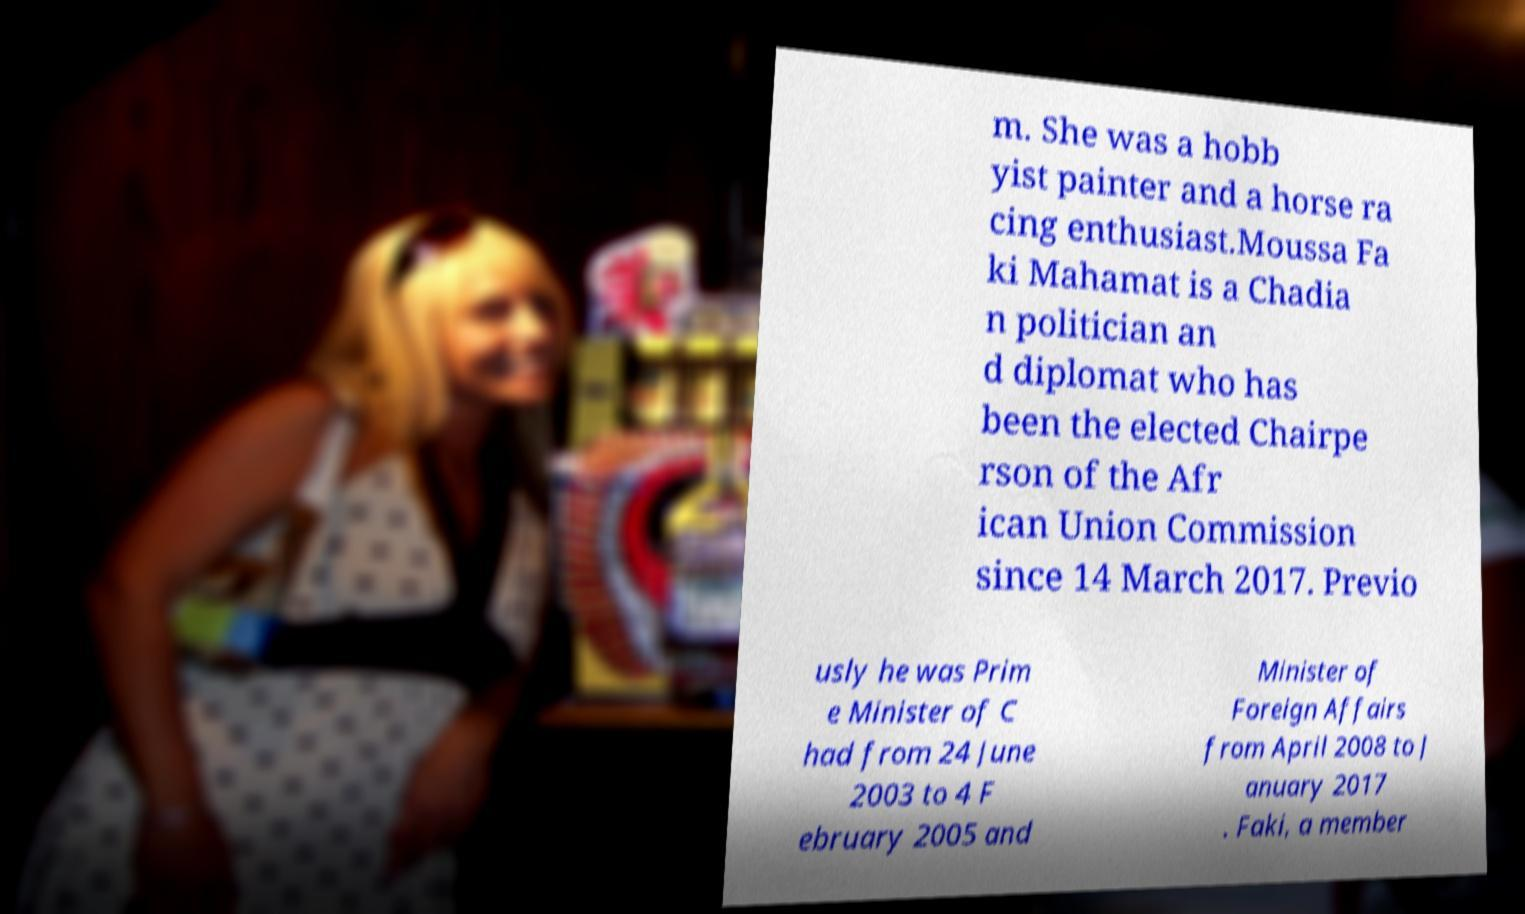What messages or text are displayed in this image? I need them in a readable, typed format. m. She was a hobb yist painter and a horse ra cing enthusiast.Moussa Fa ki Mahamat is a Chadia n politician an d diplomat who has been the elected Chairpe rson of the Afr ican Union Commission since 14 March 2017. Previo usly he was Prim e Minister of C had from 24 June 2003 to 4 F ebruary 2005 and Minister of Foreign Affairs from April 2008 to J anuary 2017 . Faki, a member 